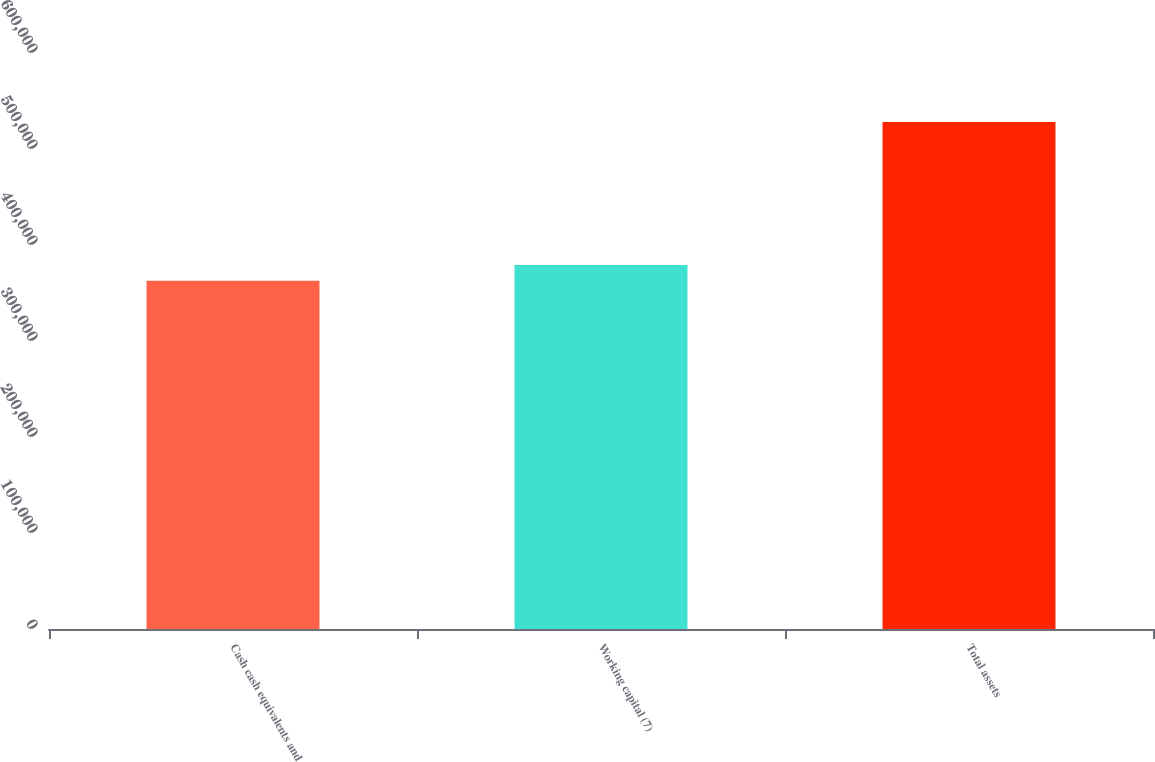Convert chart to OTSL. <chart><loc_0><loc_0><loc_500><loc_500><bar_chart><fcel>Cash cash equivalents and<fcel>Working capital (7)<fcel>Total assets<nl><fcel>362647<fcel>379186<fcel>528042<nl></chart> 